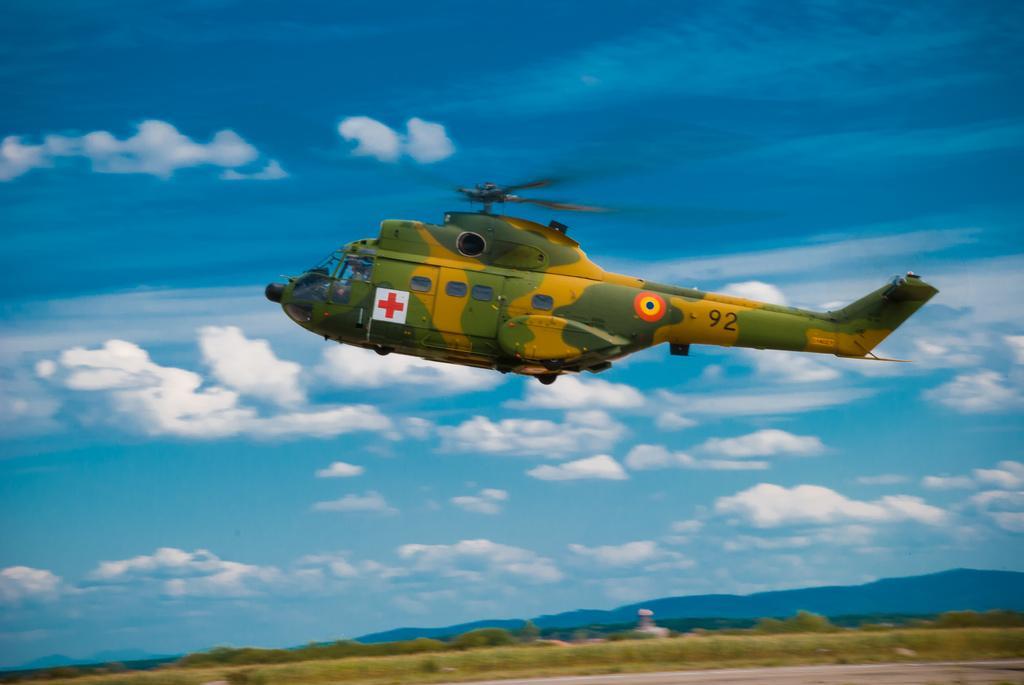Please provide a concise description of this image. In this image I can see a camouflage colour helicopter in the air. I can also see few logos and something is written on this helicopter. In the background I can see clouds and the sky. 